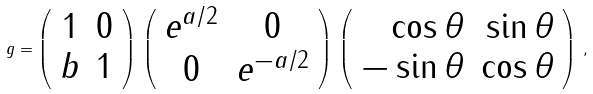Convert formula to latex. <formula><loc_0><loc_0><loc_500><loc_500>g = \left ( \begin{array} { c c } 1 & 0 \\ b & 1 \end{array} \right ) \, \left ( \begin{array} { c c } e ^ { a / 2 } & 0 \\ 0 & e ^ { - a / 2 } \end{array} \right ) \, \left ( \begin{array} { r r } \cos \theta & \sin \theta \\ - \sin \theta & \cos \theta \end{array} \right ) \, ,</formula> 